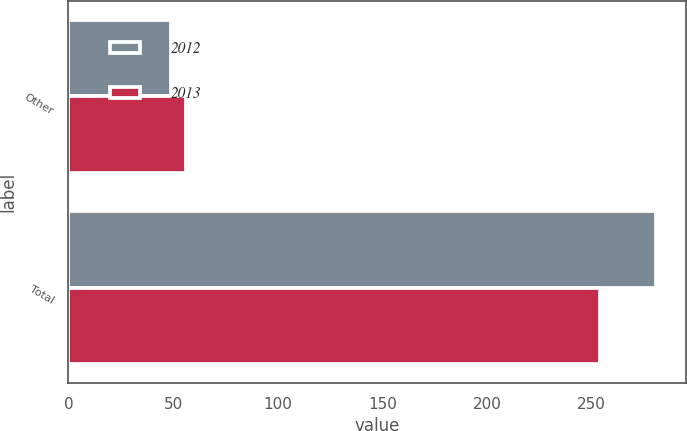Convert chart to OTSL. <chart><loc_0><loc_0><loc_500><loc_500><stacked_bar_chart><ecel><fcel>Other<fcel>Total<nl><fcel>2012<fcel>49<fcel>281<nl><fcel>2013<fcel>56<fcel>254<nl></chart> 